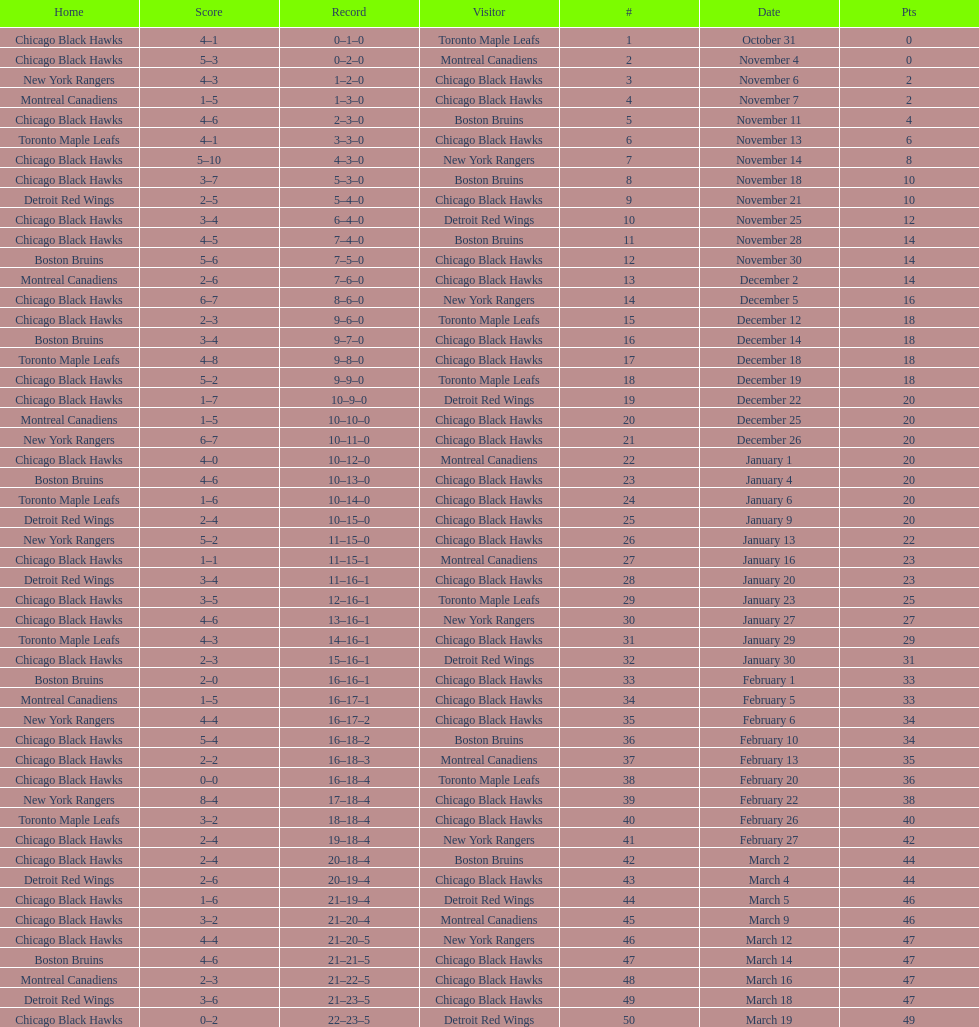Who was the next team that the boston bruins played after november 11? Chicago Black Hawks. 